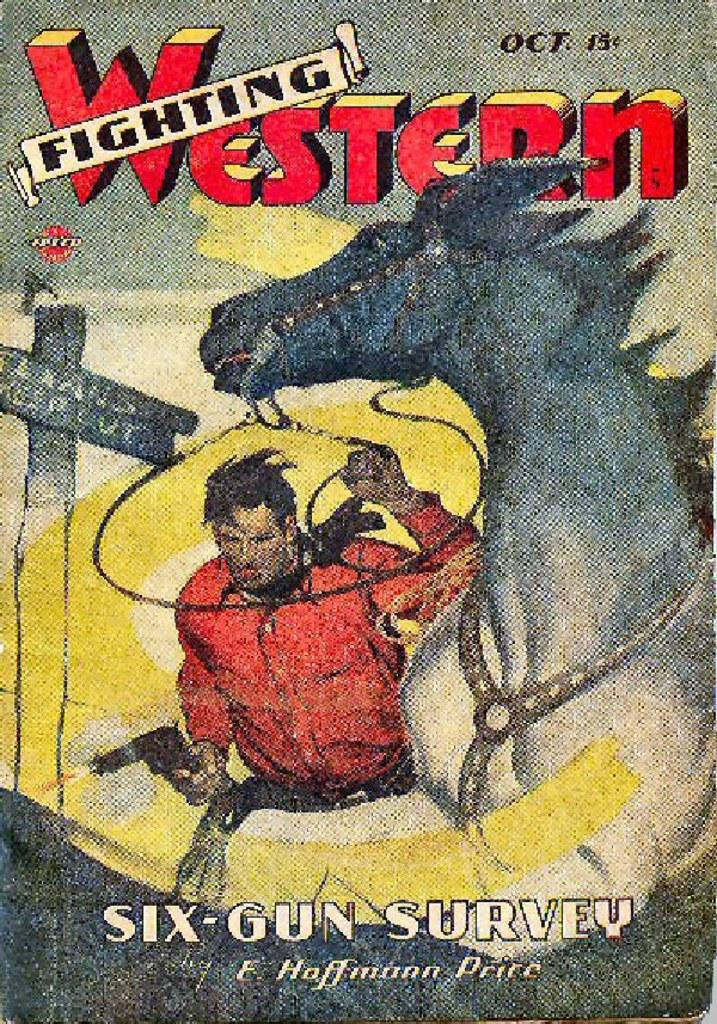Provide a one-sentence caption for the provided image. The cover of Six-Gun Survey has a drawing of a cowboy and a horse. 